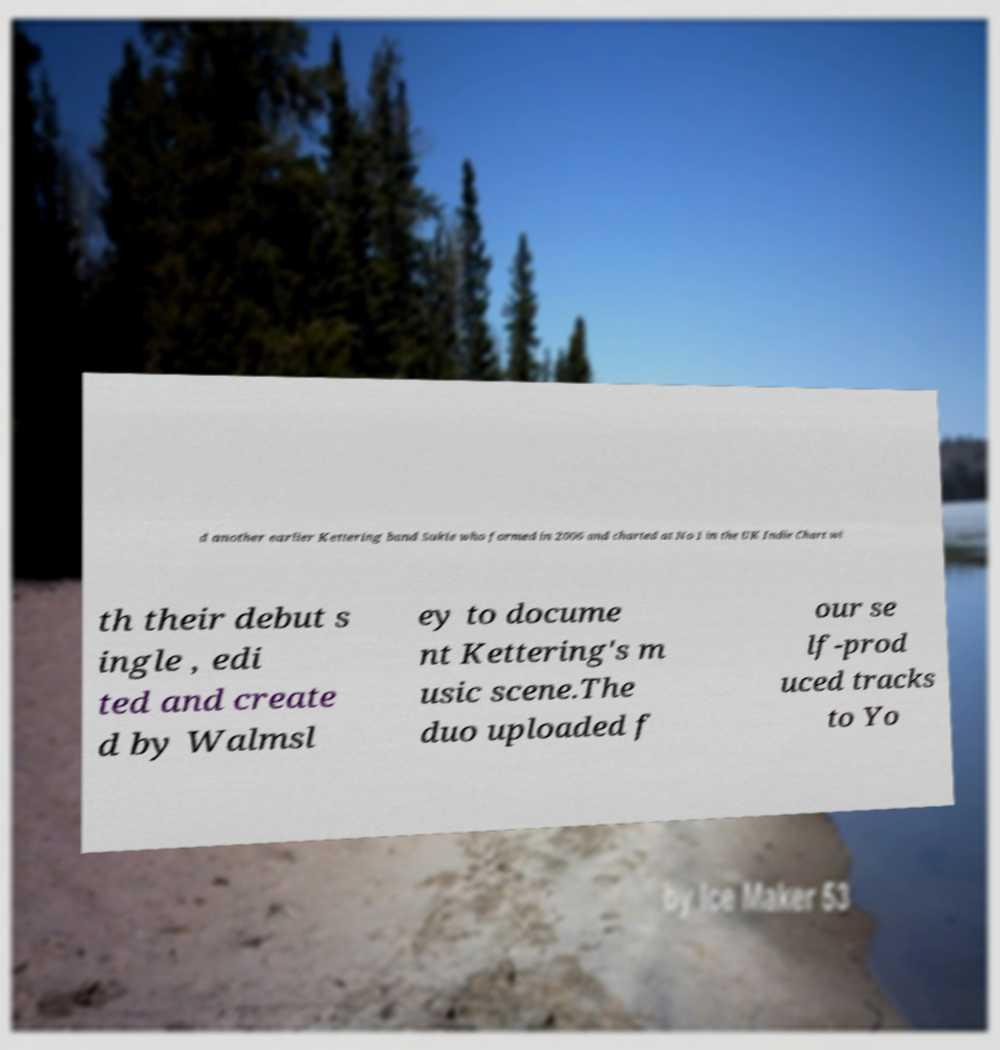Could you extract and type out the text from this image? d another earlier Kettering band Sukie who formed in 2006 and charted at No 1 in the UK Indie Chart wi th their debut s ingle , edi ted and create d by Walmsl ey to docume nt Kettering's m usic scene.The duo uploaded f our se lf-prod uced tracks to Yo 